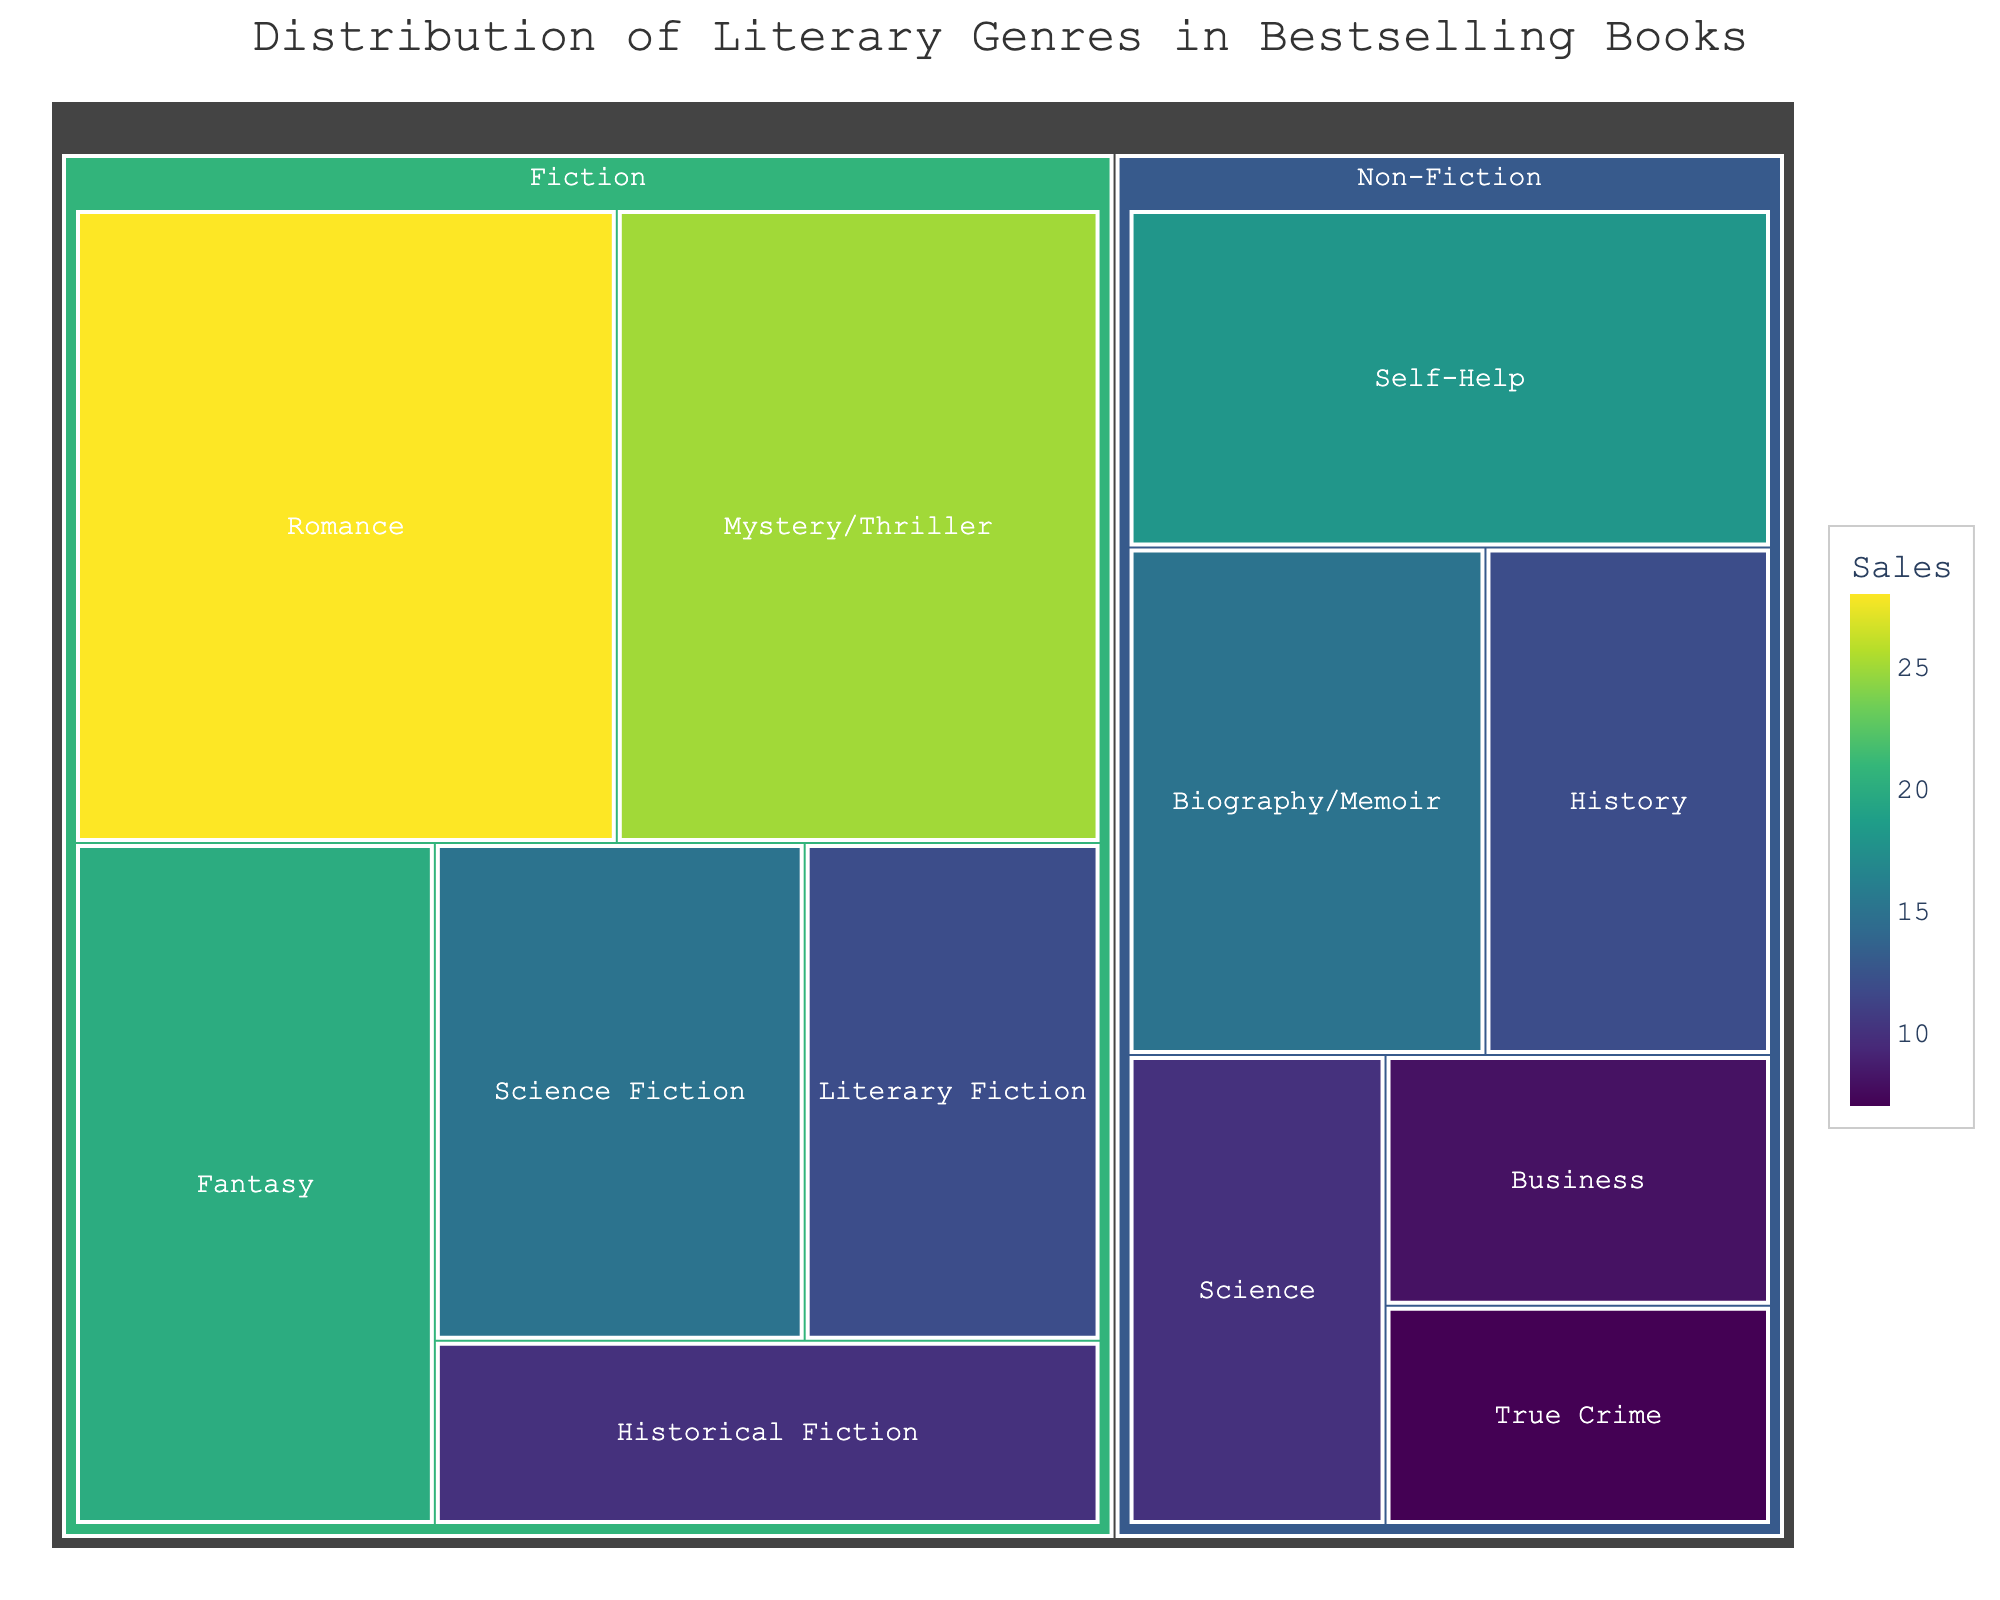What is the largest genre in the Fiction category? Look at the portion of the treemap labeled "Fiction" and locate the largest block. Identify the corresponding genre.
Answer: Romance What is the combined sales of Fiction categories? Add the sales numbers for all Fiction genres: 28 (Romance) + 25 (Mystery/Thriller) + 20 (Fantasy) + 15 (Science Fiction) + 12 (Literary Fiction) + 10 (Historical Fiction). This results in a total sales sum of 110.
Answer: 110 Which category has higher total sales, Fiction or Non-Fiction? Sum the total sales for Fiction (110) and Non-Fiction (18 + 15 + 12 + 10 + 8 + 7 = 70). Compare these sums to determine which is higher.
Answer: Fiction What is the least popular genre in Non-Fiction? Identify the smallest block under the Non-Fiction label. The genre is "True Crime" with 7 sales.
Answer: True Crime How much more popular is Romance compared to Fantasy? Subtract the sales of Fantasy (20) from the sales of Romance (28). The difference is 8.
Answer: 8 What is the distribution range of sales among the Non-Fiction genres? Identify the maximum (18 for Self-Help) and minimum (7 for True Crime) sales in the Non-Fiction category. Subtract the minimum from the maximum (18 - 7).
Answer: 11 What genres form the top three in overall sales? Combine the Fiction and Non-Fiction genres into one pool. Identify the top three based on sales: Romance (28), Mystery/Thriller (25), and Fantasy (20).
Answer: Romance, Mystery/Thriller, Fantasy Which category has a more diverse spread of sales figures, Fiction or Non-Fiction? Compare the range and distribution of sales values in both categories. Fiction ranges from 28 to 10, whereas Non-Fiction ranges from 18 to 7. Fiction shows a wider range of higher numbers, indicating greater diversity.
Answer: Fiction 